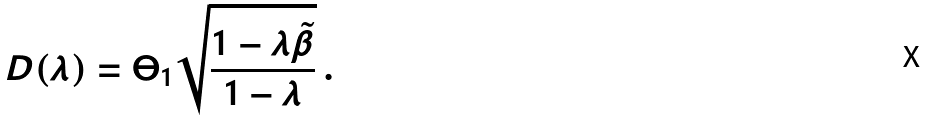Convert formula to latex. <formula><loc_0><loc_0><loc_500><loc_500>D ( \lambda ) = \Theta _ { 1 } \sqrt { \frac { 1 - \lambda \tilde { \beta } } { 1 - \lambda } } \, .</formula> 